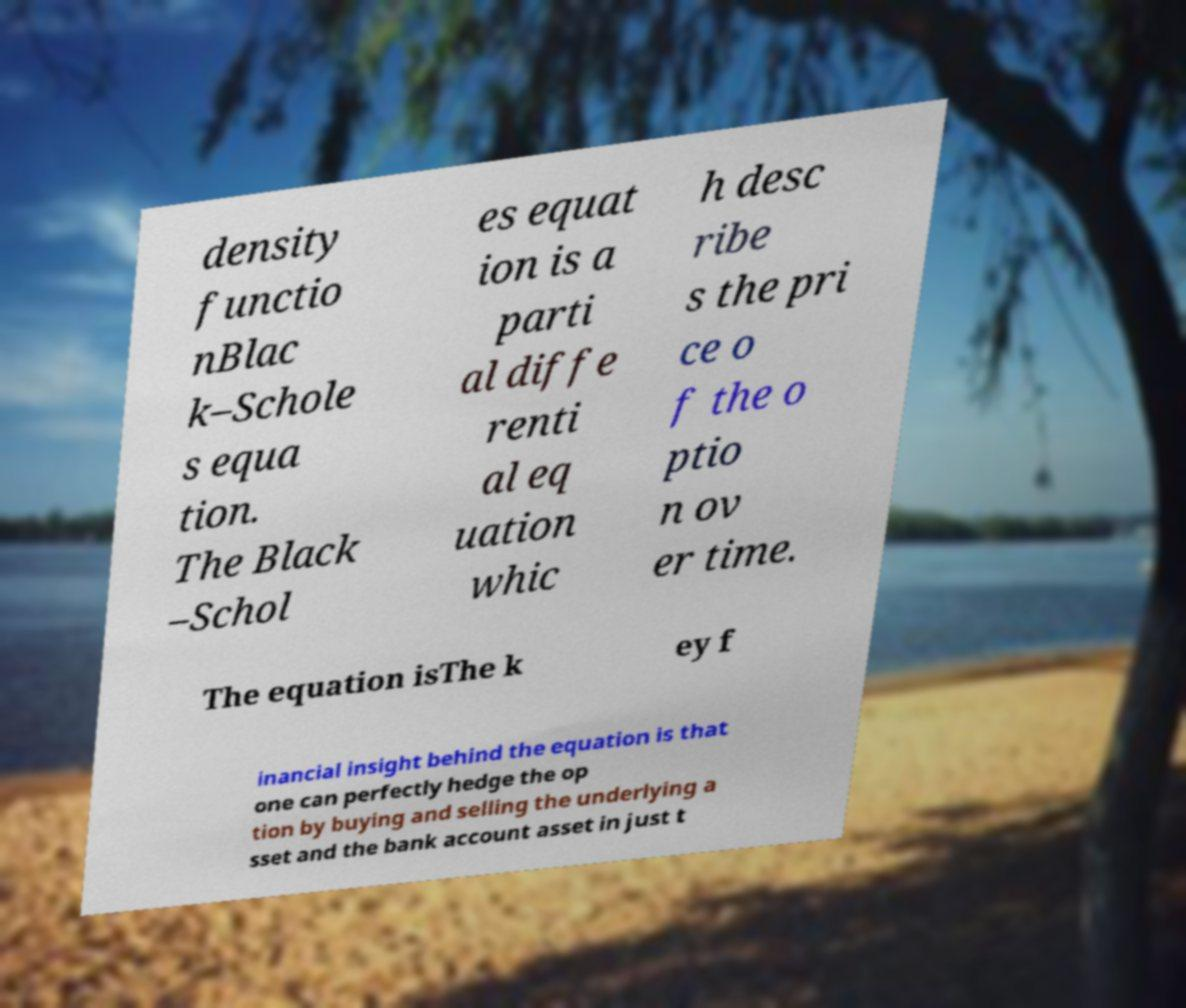For documentation purposes, I need the text within this image transcribed. Could you provide that? density functio nBlac k–Schole s equa tion. The Black –Schol es equat ion is a parti al diffe renti al eq uation whic h desc ribe s the pri ce o f the o ptio n ov er time. The equation isThe k ey f inancial insight behind the equation is that one can perfectly hedge the op tion by buying and selling the underlying a sset and the bank account asset in just t 